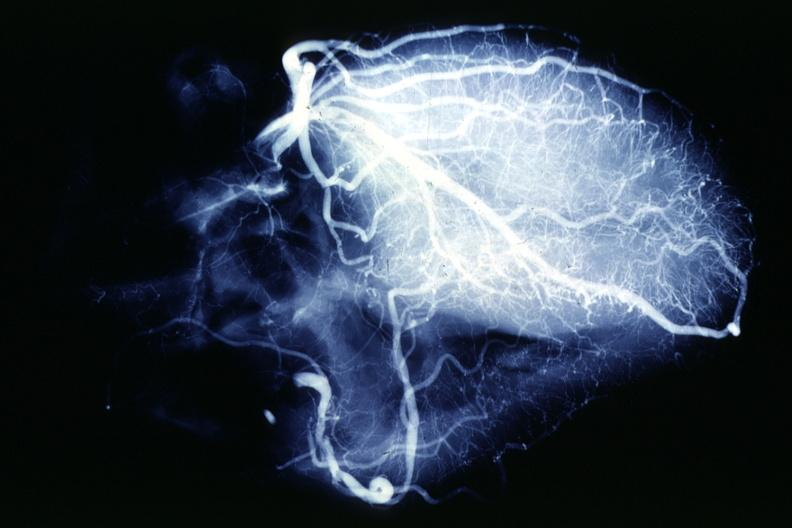what does this image show?
Answer the question using a single word or phrase. X-ray postmortcoronary angiogram rather typical example of proximal lesions 